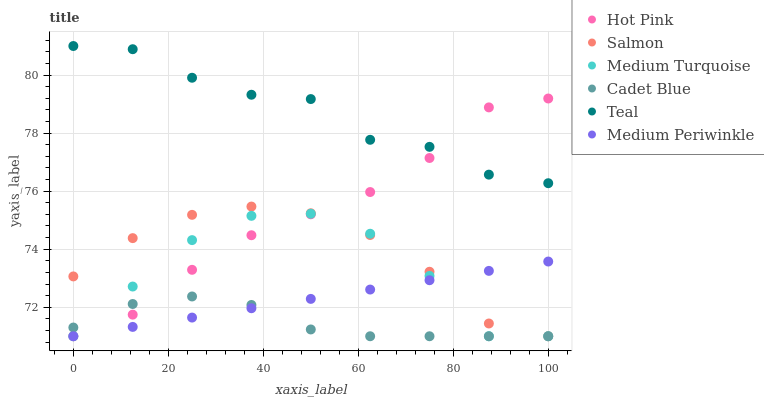Does Cadet Blue have the minimum area under the curve?
Answer yes or no. Yes. Does Teal have the maximum area under the curve?
Answer yes or no. Yes. Does Medium Turquoise have the minimum area under the curve?
Answer yes or no. No. Does Medium Turquoise have the maximum area under the curve?
Answer yes or no. No. Is Medium Periwinkle the smoothest?
Answer yes or no. Yes. Is Medium Turquoise the roughest?
Answer yes or no. Yes. Is Salmon the smoothest?
Answer yes or no. No. Is Salmon the roughest?
Answer yes or no. No. Does Cadet Blue have the lowest value?
Answer yes or no. Yes. Does Teal have the lowest value?
Answer yes or no. No. Does Teal have the highest value?
Answer yes or no. Yes. Does Medium Turquoise have the highest value?
Answer yes or no. No. Is Medium Turquoise less than Teal?
Answer yes or no. Yes. Is Teal greater than Medium Periwinkle?
Answer yes or no. Yes. Does Medium Periwinkle intersect Medium Turquoise?
Answer yes or no. Yes. Is Medium Periwinkle less than Medium Turquoise?
Answer yes or no. No. Is Medium Periwinkle greater than Medium Turquoise?
Answer yes or no. No. Does Medium Turquoise intersect Teal?
Answer yes or no. No. 